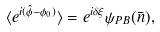<formula> <loc_0><loc_0><loc_500><loc_500>\langle e ^ { i ( { \hat { \phi } } - \phi _ { 0 } ) } \rangle = e ^ { i \delta \xi } \psi _ { P B } ( \bar { n } ) ,</formula> 